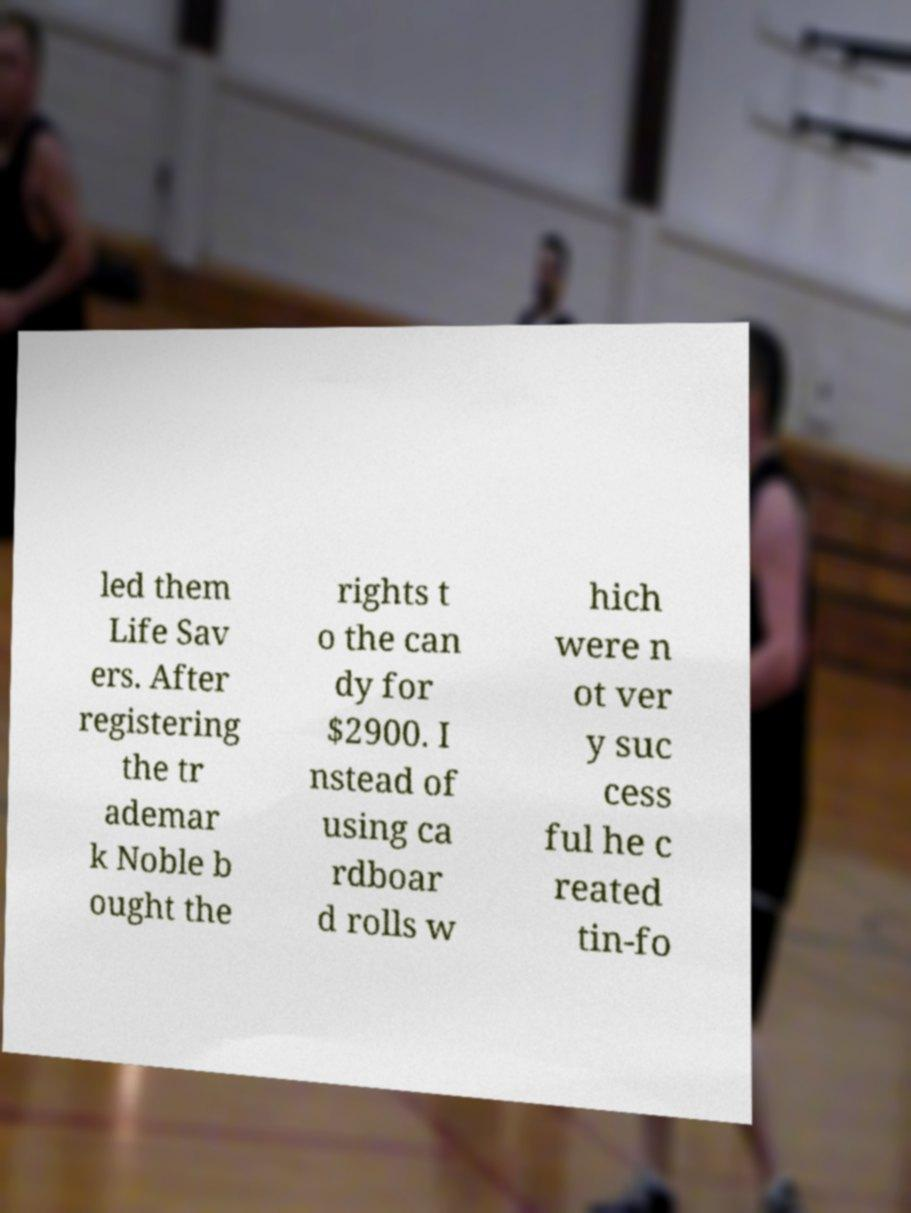For documentation purposes, I need the text within this image transcribed. Could you provide that? led them Life Sav ers. After registering the tr ademar k Noble b ought the rights t o the can dy for $2900. I nstead of using ca rdboar d rolls w hich were n ot ver y suc cess ful he c reated tin-fo 